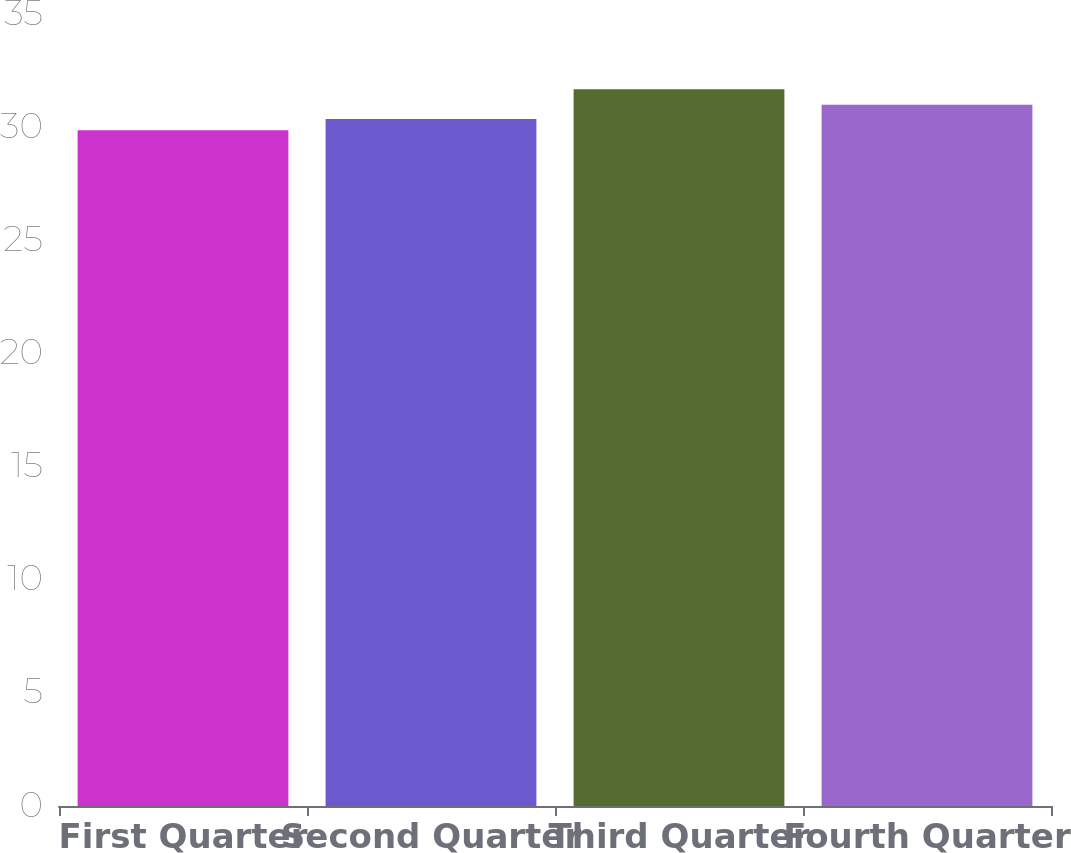Convert chart to OTSL. <chart><loc_0><loc_0><loc_500><loc_500><bar_chart><fcel>First Quarter<fcel>Second Quarter<fcel>Third Quarter<fcel>Fourth Quarter<nl><fcel>29.86<fcel>30.36<fcel>31.67<fcel>30.99<nl></chart> 